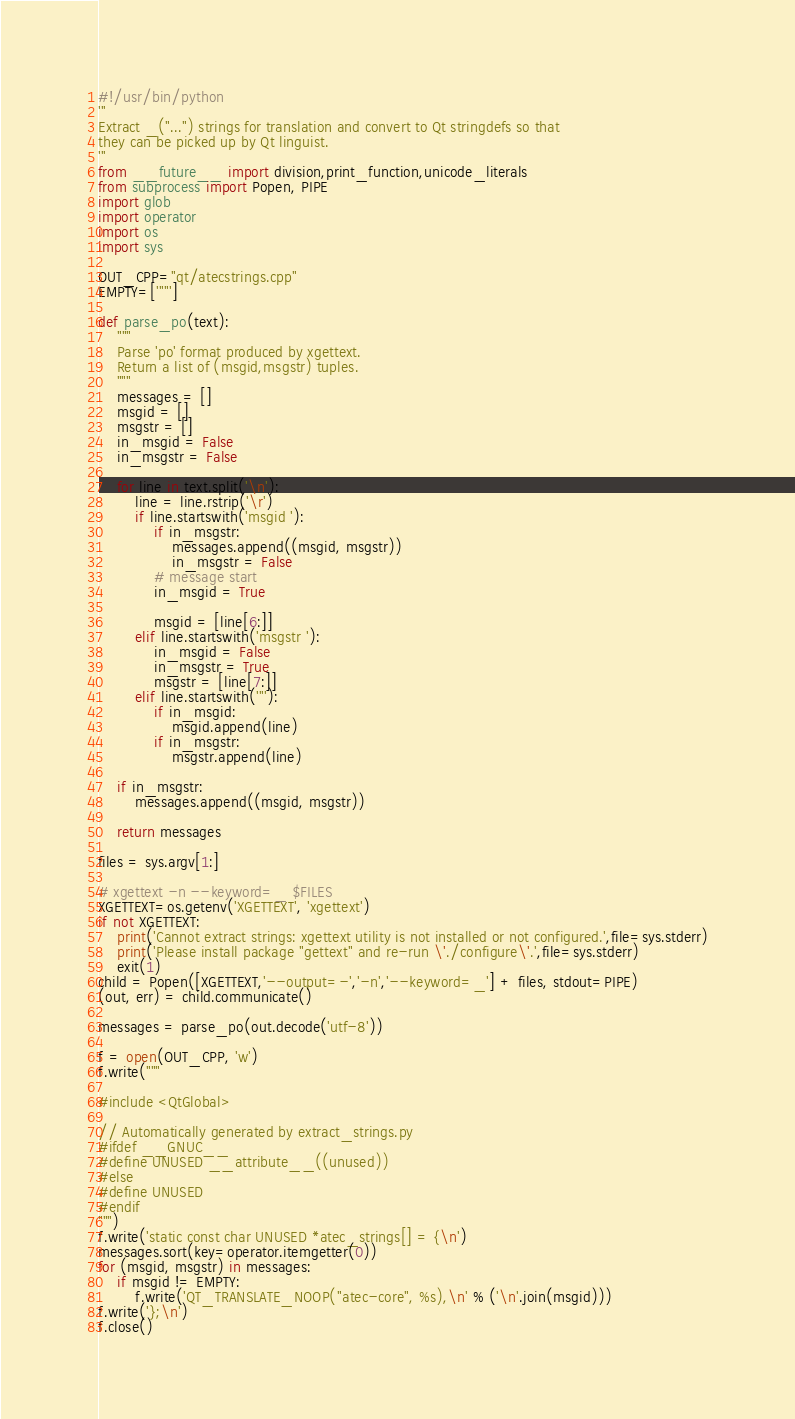<code> <loc_0><loc_0><loc_500><loc_500><_Python_>#!/usr/bin/python
'''
Extract _("...") strings for translation and convert to Qt stringdefs so that
they can be picked up by Qt linguist.
'''
from __future__ import division,print_function,unicode_literals
from subprocess import Popen, PIPE
import glob
import operator
import os
import sys

OUT_CPP="qt/atecstrings.cpp"
EMPTY=['""']

def parse_po(text):
    """
    Parse 'po' format produced by xgettext.
    Return a list of (msgid,msgstr) tuples.
    """
    messages = []
    msgid = []
    msgstr = []
    in_msgid = False
    in_msgstr = False

    for line in text.split('\n'):
        line = line.rstrip('\r')
        if line.startswith('msgid '):
            if in_msgstr:
                messages.append((msgid, msgstr))
                in_msgstr = False
            # message start
            in_msgid = True

            msgid = [line[6:]]
        elif line.startswith('msgstr '):
            in_msgid = False
            in_msgstr = True
            msgstr = [line[7:]]
        elif line.startswith('"'):
            if in_msgid:
                msgid.append(line)
            if in_msgstr:
                msgstr.append(line)

    if in_msgstr:
        messages.append((msgid, msgstr))

    return messages

files = sys.argv[1:]

# xgettext -n --keyword=_ $FILES
XGETTEXT=os.getenv('XGETTEXT', 'xgettext')
if not XGETTEXT:
    print('Cannot extract strings: xgettext utility is not installed or not configured.',file=sys.stderr)
    print('Please install package "gettext" and re-run \'./configure\'.',file=sys.stderr)
    exit(1)
child = Popen([XGETTEXT,'--output=-','-n','--keyword=_'] + files, stdout=PIPE)
(out, err) = child.communicate()

messages = parse_po(out.decode('utf-8'))

f = open(OUT_CPP, 'w')
f.write("""

#include <QtGlobal>

// Automatically generated by extract_strings.py
#ifdef __GNUC__
#define UNUSED __attribute__((unused))
#else
#define UNUSED
#endif
""")
f.write('static const char UNUSED *atec_strings[] = {\n')
messages.sort(key=operator.itemgetter(0))
for (msgid, msgstr) in messages:
    if msgid != EMPTY:
        f.write('QT_TRANSLATE_NOOP("atec-core", %s),\n' % ('\n'.join(msgid)))
f.write('};\n')
f.close()
</code> 